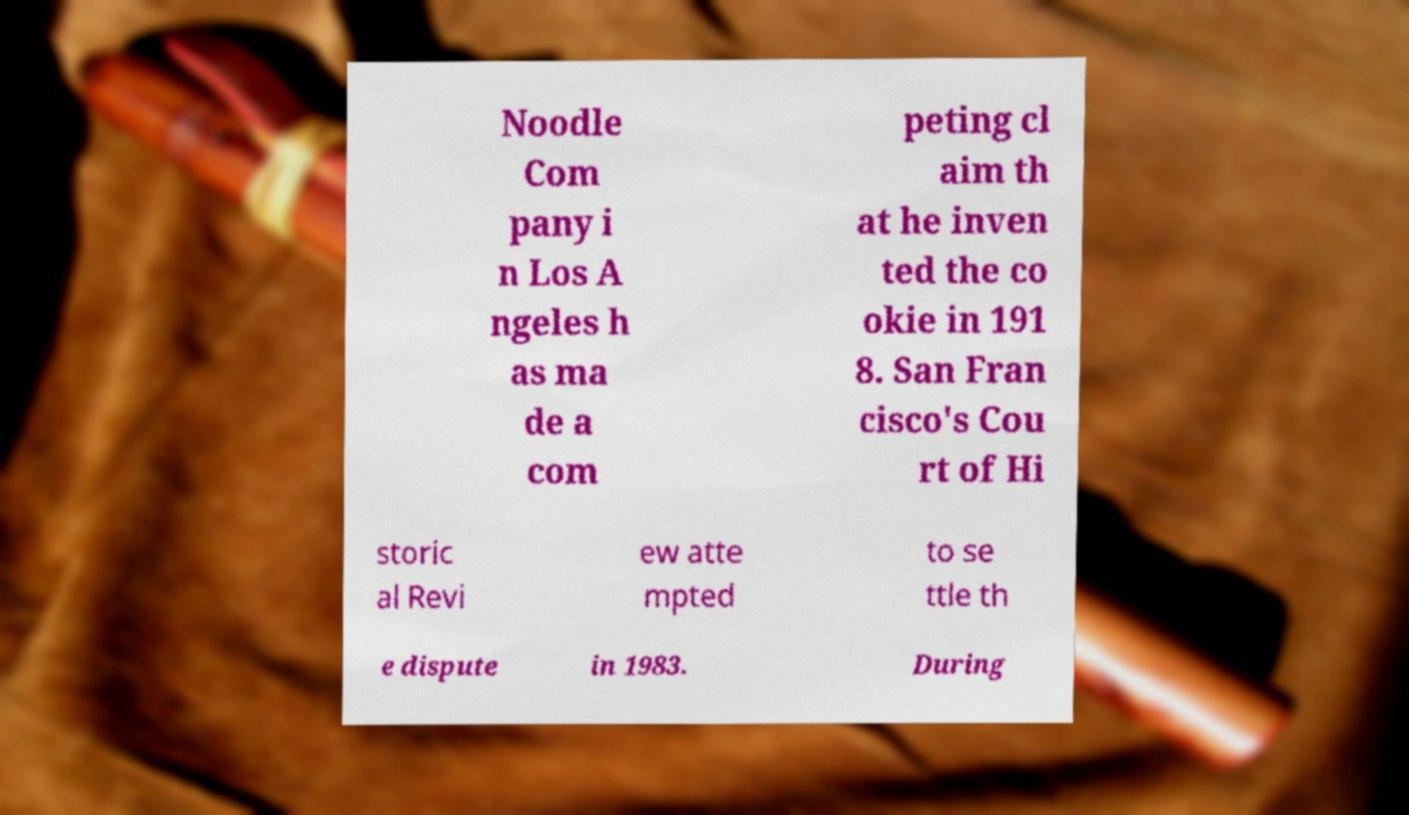There's text embedded in this image that I need extracted. Can you transcribe it verbatim? Noodle Com pany i n Los A ngeles h as ma de a com peting cl aim th at he inven ted the co okie in 191 8. San Fran cisco's Cou rt of Hi storic al Revi ew atte mpted to se ttle th e dispute in 1983. During 